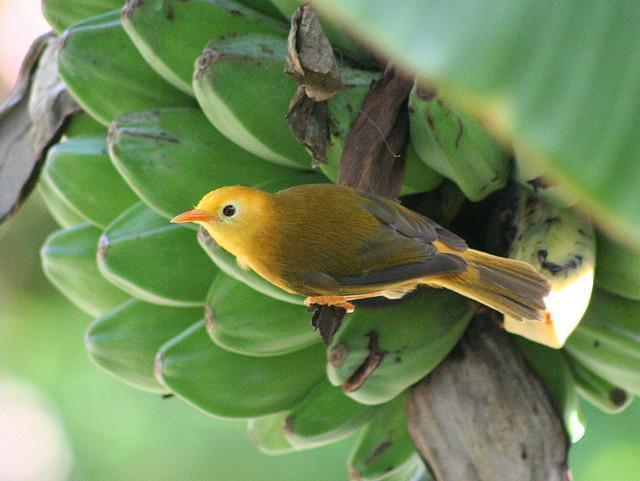How many bananas can be seen?
Give a very brief answer. 4. 